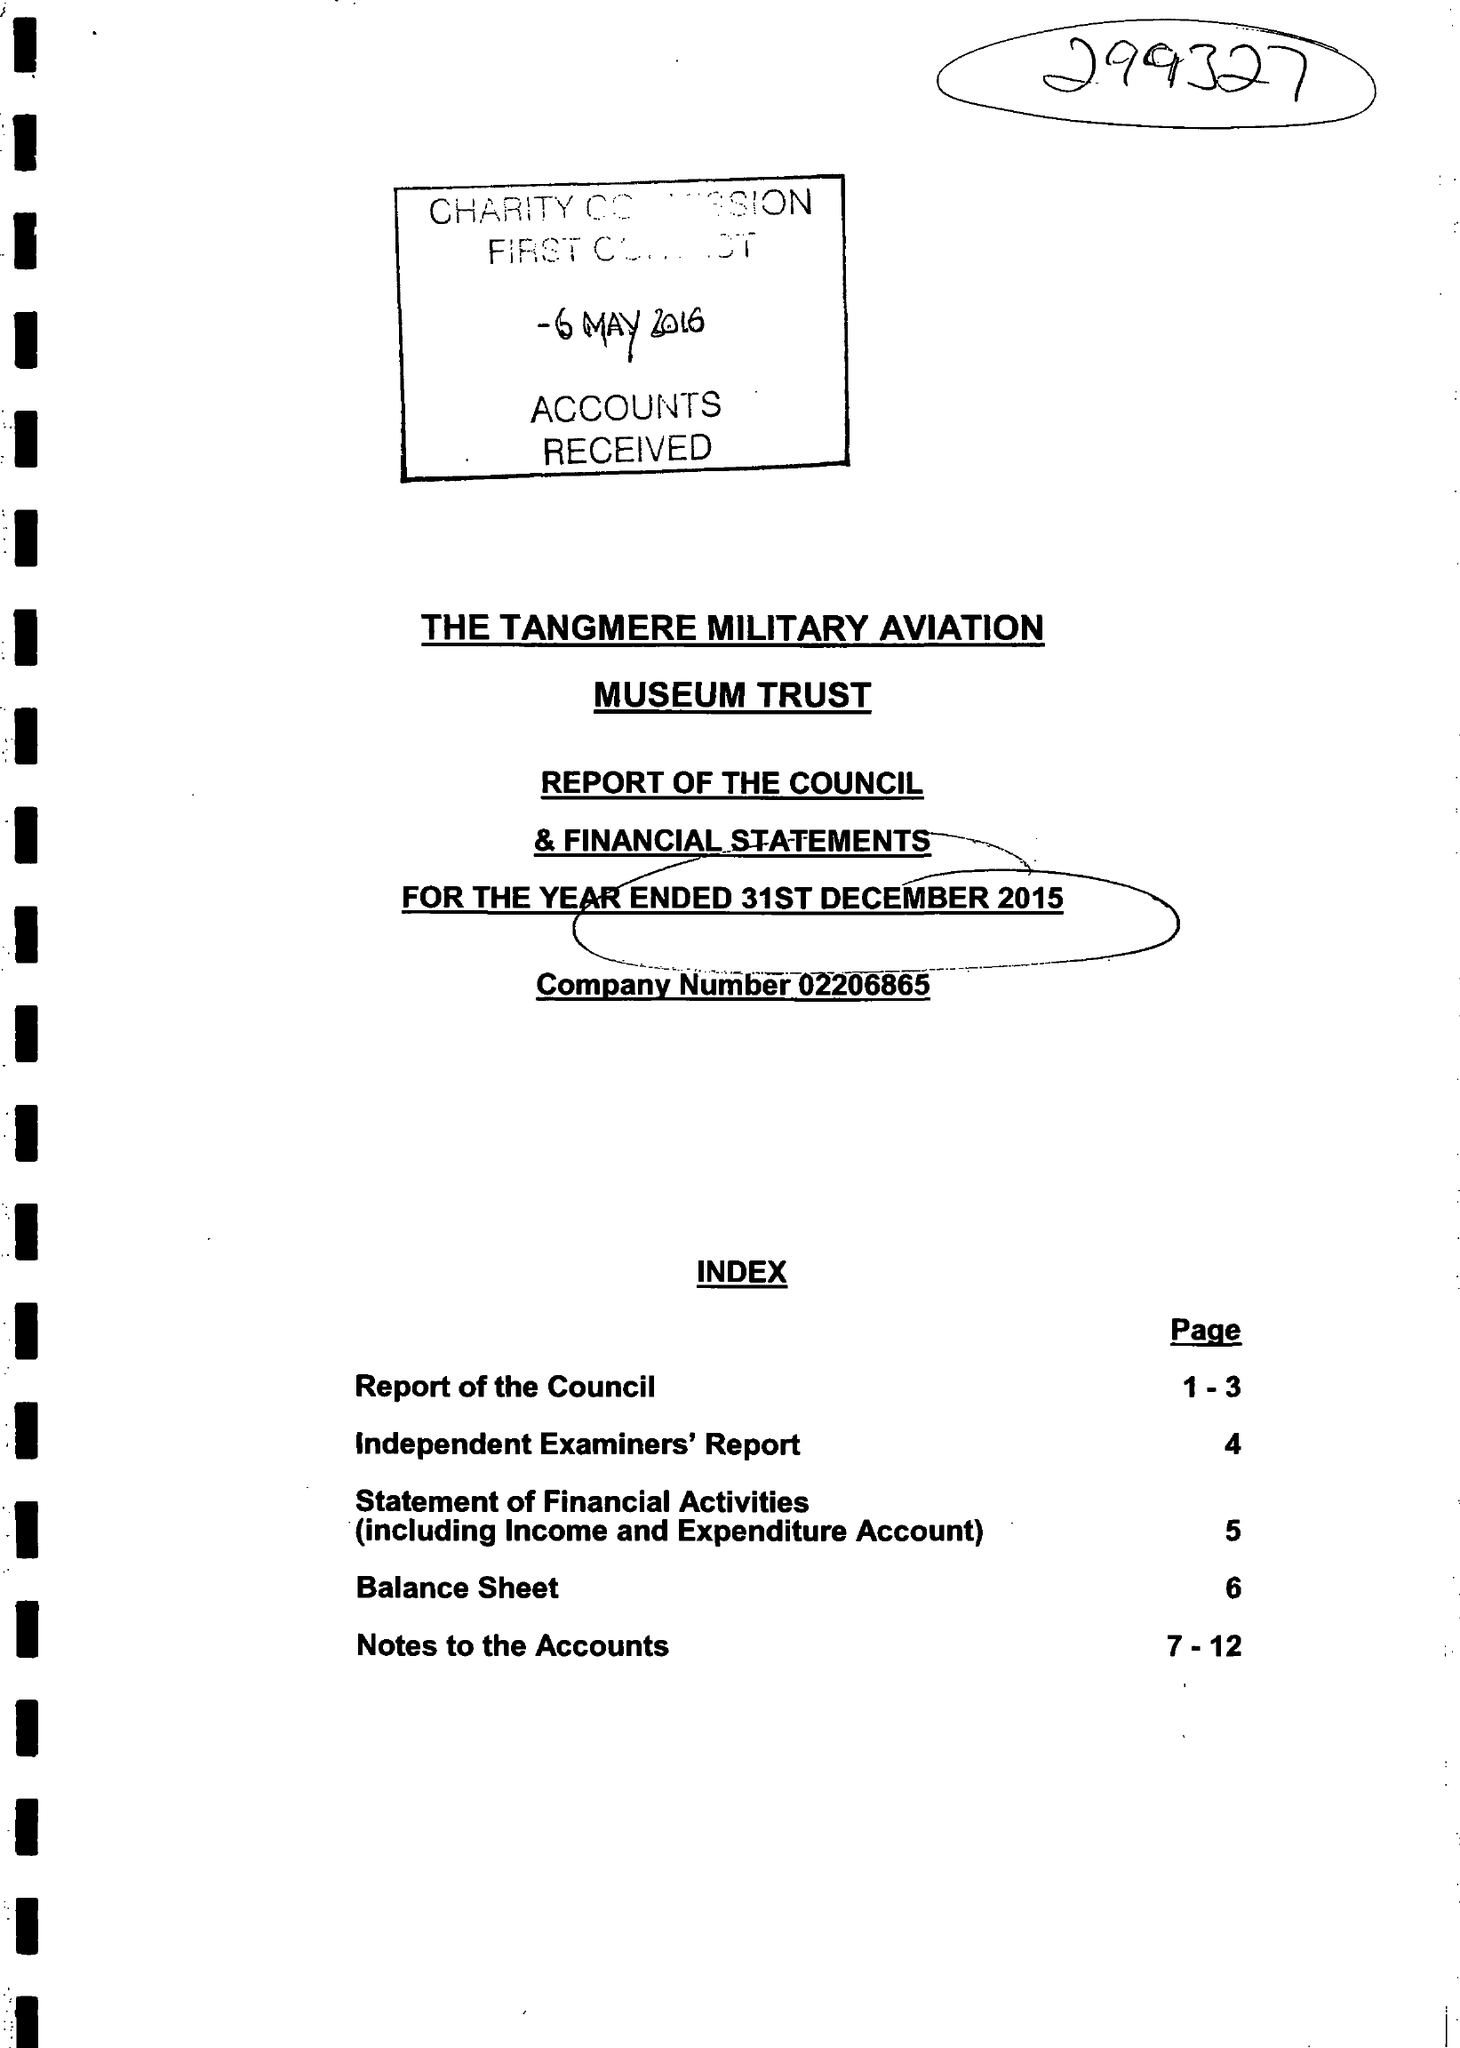What is the value for the charity_number?
Answer the question using a single word or phrase. 299327 